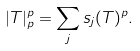<formula> <loc_0><loc_0><loc_500><loc_500>| T | _ { p } ^ { p } = \sum _ { j } s _ { j } ( T ) ^ { p } .</formula> 